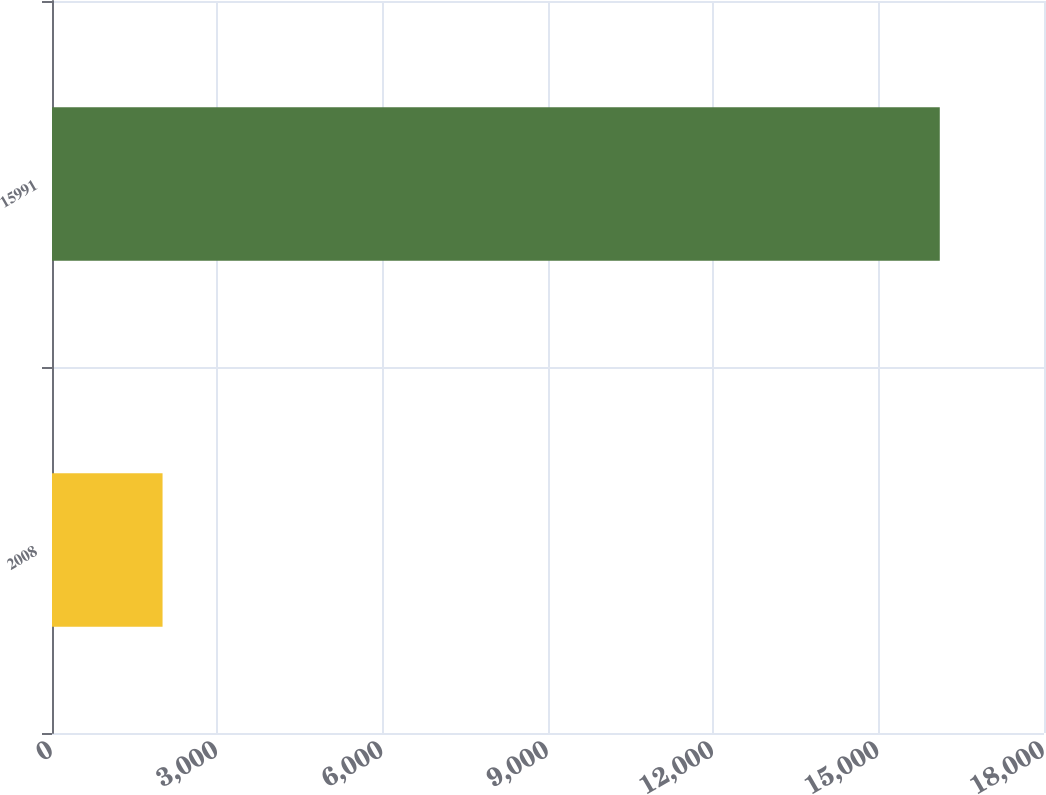Convert chart to OTSL. <chart><loc_0><loc_0><loc_500><loc_500><bar_chart><fcel>2008<fcel>15991<nl><fcel>2006<fcel>16109<nl></chart> 